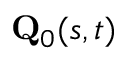Convert formula to latex. <formula><loc_0><loc_0><loc_500><loc_500>Q _ { 0 } ( s , t )</formula> 